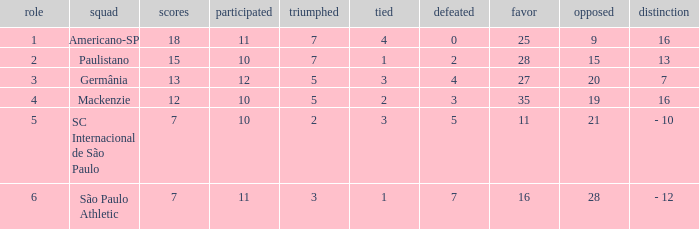Help me parse the entirety of this table. {'header': ['role', 'squad', 'scores', 'participated', 'triumphed', 'tied', 'defeated', 'favor', 'opposed', 'distinction'], 'rows': [['1', 'Americano-SP', '18', '11', '7', '4', '0', '25', '9', '16'], ['2', 'Paulistano', '15', '10', '7', '1', '2', '28', '15', '13'], ['3', 'Germânia', '13', '12', '5', '3', '4', '27', '20', '7'], ['4', 'Mackenzie', '12', '10', '5', '2', '3', '35', '19', '16'], ['5', 'SC Internacional de São Paulo', '7', '10', '2', '3', '5', '11', '21', '- 10'], ['6', 'São Paulo Athletic', '7', '11', '3', '1', '7', '16', '28', '- 12']]} Name the least for when played is 12 27.0. 